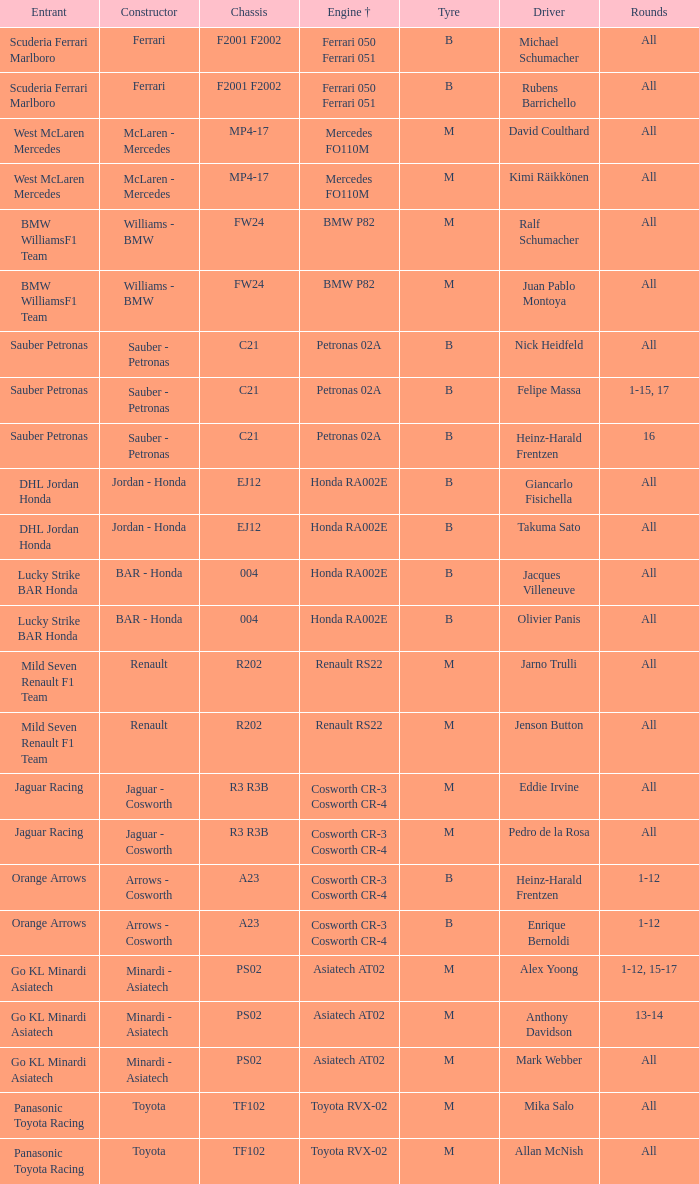Could you help me parse every detail presented in this table? {'header': ['Entrant', 'Constructor', 'Chassis', 'Engine †', 'Tyre', 'Driver', 'Rounds'], 'rows': [['Scuderia Ferrari Marlboro', 'Ferrari', 'F2001 F2002', 'Ferrari 050 Ferrari 051', 'B', 'Michael Schumacher', 'All'], ['Scuderia Ferrari Marlboro', 'Ferrari', 'F2001 F2002', 'Ferrari 050 Ferrari 051', 'B', 'Rubens Barrichello', 'All'], ['West McLaren Mercedes', 'McLaren - Mercedes', 'MP4-17', 'Mercedes FO110M', 'M', 'David Coulthard', 'All'], ['West McLaren Mercedes', 'McLaren - Mercedes', 'MP4-17', 'Mercedes FO110M', 'M', 'Kimi Räikkönen', 'All'], ['BMW WilliamsF1 Team', 'Williams - BMW', 'FW24', 'BMW P82', 'M', 'Ralf Schumacher', 'All'], ['BMW WilliamsF1 Team', 'Williams - BMW', 'FW24', 'BMW P82', 'M', 'Juan Pablo Montoya', 'All'], ['Sauber Petronas', 'Sauber - Petronas', 'C21', 'Petronas 02A', 'B', 'Nick Heidfeld', 'All'], ['Sauber Petronas', 'Sauber - Petronas', 'C21', 'Petronas 02A', 'B', 'Felipe Massa', '1-15, 17'], ['Sauber Petronas', 'Sauber - Petronas', 'C21', 'Petronas 02A', 'B', 'Heinz-Harald Frentzen', '16'], ['DHL Jordan Honda', 'Jordan - Honda', 'EJ12', 'Honda RA002E', 'B', 'Giancarlo Fisichella', 'All'], ['DHL Jordan Honda', 'Jordan - Honda', 'EJ12', 'Honda RA002E', 'B', 'Takuma Sato', 'All'], ['Lucky Strike BAR Honda', 'BAR - Honda', '004', 'Honda RA002E', 'B', 'Jacques Villeneuve', 'All'], ['Lucky Strike BAR Honda', 'BAR - Honda', '004', 'Honda RA002E', 'B', 'Olivier Panis', 'All'], ['Mild Seven Renault F1 Team', 'Renault', 'R202', 'Renault RS22', 'M', 'Jarno Trulli', 'All'], ['Mild Seven Renault F1 Team', 'Renault', 'R202', 'Renault RS22', 'M', 'Jenson Button', 'All'], ['Jaguar Racing', 'Jaguar - Cosworth', 'R3 R3B', 'Cosworth CR-3 Cosworth CR-4', 'M', 'Eddie Irvine', 'All'], ['Jaguar Racing', 'Jaguar - Cosworth', 'R3 R3B', 'Cosworth CR-3 Cosworth CR-4', 'M', 'Pedro de la Rosa', 'All'], ['Orange Arrows', 'Arrows - Cosworth', 'A23', 'Cosworth CR-3 Cosworth CR-4', 'B', 'Heinz-Harald Frentzen', '1-12'], ['Orange Arrows', 'Arrows - Cosworth', 'A23', 'Cosworth CR-3 Cosworth CR-4', 'B', 'Enrique Bernoldi', '1-12'], ['Go KL Minardi Asiatech', 'Minardi - Asiatech', 'PS02', 'Asiatech AT02', 'M', 'Alex Yoong', '1-12, 15-17'], ['Go KL Minardi Asiatech', 'Minardi - Asiatech', 'PS02', 'Asiatech AT02', 'M', 'Anthony Davidson', '13-14'], ['Go KL Minardi Asiatech', 'Minardi - Asiatech', 'PS02', 'Asiatech AT02', 'M', 'Mark Webber', 'All'], ['Panasonic Toyota Racing', 'Toyota', 'TF102', 'Toyota RVX-02', 'M', 'Mika Salo', 'All'], ['Panasonic Toyota Racing', 'Toyota', 'TF102', 'Toyota RVX-02', 'M', 'Allan McNish', 'All']]} When the bmw p82 engine is involved, who is the contender? BMW WilliamsF1 Team, BMW WilliamsF1 Team. 